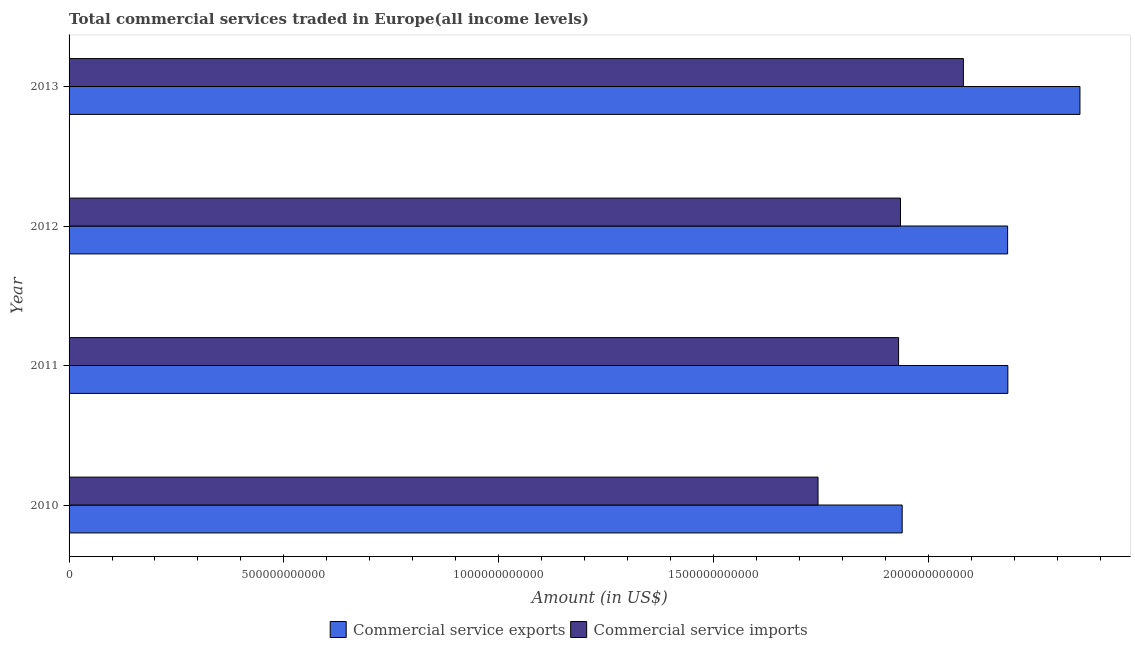Are the number of bars on each tick of the Y-axis equal?
Ensure brevity in your answer.  Yes. How many bars are there on the 2nd tick from the top?
Provide a short and direct response. 2. How many bars are there on the 1st tick from the bottom?
Keep it short and to the point. 2. What is the label of the 4th group of bars from the top?
Provide a succinct answer. 2010. In how many cases, is the number of bars for a given year not equal to the number of legend labels?
Your answer should be compact. 0. What is the amount of commercial service imports in 2013?
Your answer should be compact. 2.08e+12. Across all years, what is the maximum amount of commercial service exports?
Provide a short and direct response. 2.35e+12. Across all years, what is the minimum amount of commercial service exports?
Offer a very short reply. 1.94e+12. In which year was the amount of commercial service exports minimum?
Make the answer very short. 2010. What is the total amount of commercial service exports in the graph?
Offer a terse response. 8.66e+12. What is the difference between the amount of commercial service imports in 2011 and that in 2012?
Ensure brevity in your answer.  -4.48e+09. What is the difference between the amount of commercial service exports in 2011 and the amount of commercial service imports in 2012?
Give a very brief answer. 2.50e+11. What is the average amount of commercial service exports per year?
Your response must be concise. 2.17e+12. In the year 2011, what is the difference between the amount of commercial service exports and amount of commercial service imports?
Your answer should be compact. 2.54e+11. In how many years, is the amount of commercial service exports greater than 1100000000000 US$?
Give a very brief answer. 4. What is the ratio of the amount of commercial service imports in 2010 to that in 2011?
Your answer should be compact. 0.9. What is the difference between the highest and the second highest amount of commercial service imports?
Provide a succinct answer. 1.46e+11. What is the difference between the highest and the lowest amount of commercial service exports?
Your answer should be very brief. 4.14e+11. In how many years, is the amount of commercial service imports greater than the average amount of commercial service imports taken over all years?
Offer a very short reply. 3. Is the sum of the amount of commercial service exports in 2010 and 2012 greater than the maximum amount of commercial service imports across all years?
Your response must be concise. Yes. What does the 1st bar from the top in 2010 represents?
Your response must be concise. Commercial service imports. What does the 1st bar from the bottom in 2010 represents?
Your response must be concise. Commercial service exports. How many bars are there?
Your answer should be compact. 8. What is the difference between two consecutive major ticks on the X-axis?
Your answer should be compact. 5.00e+11. Are the values on the major ticks of X-axis written in scientific E-notation?
Offer a very short reply. No. Where does the legend appear in the graph?
Offer a terse response. Bottom center. How are the legend labels stacked?
Ensure brevity in your answer.  Horizontal. What is the title of the graph?
Give a very brief answer. Total commercial services traded in Europe(all income levels). Does "Researchers" appear as one of the legend labels in the graph?
Your response must be concise. No. What is the label or title of the Y-axis?
Offer a very short reply. Year. What is the Amount (in US$) of Commercial service exports in 2010?
Offer a very short reply. 1.94e+12. What is the Amount (in US$) of Commercial service imports in 2010?
Offer a terse response. 1.74e+12. What is the Amount (in US$) in Commercial service exports in 2011?
Your answer should be compact. 2.19e+12. What is the Amount (in US$) of Commercial service imports in 2011?
Provide a short and direct response. 1.93e+12. What is the Amount (in US$) in Commercial service exports in 2012?
Ensure brevity in your answer.  2.18e+12. What is the Amount (in US$) of Commercial service imports in 2012?
Ensure brevity in your answer.  1.94e+12. What is the Amount (in US$) in Commercial service exports in 2013?
Ensure brevity in your answer.  2.35e+12. What is the Amount (in US$) of Commercial service imports in 2013?
Provide a succinct answer. 2.08e+12. Across all years, what is the maximum Amount (in US$) of Commercial service exports?
Give a very brief answer. 2.35e+12. Across all years, what is the maximum Amount (in US$) of Commercial service imports?
Provide a short and direct response. 2.08e+12. Across all years, what is the minimum Amount (in US$) in Commercial service exports?
Your response must be concise. 1.94e+12. Across all years, what is the minimum Amount (in US$) in Commercial service imports?
Give a very brief answer. 1.74e+12. What is the total Amount (in US$) of Commercial service exports in the graph?
Offer a very short reply. 8.66e+12. What is the total Amount (in US$) in Commercial service imports in the graph?
Your answer should be very brief. 7.69e+12. What is the difference between the Amount (in US$) of Commercial service exports in 2010 and that in 2011?
Ensure brevity in your answer.  -2.46e+11. What is the difference between the Amount (in US$) in Commercial service imports in 2010 and that in 2011?
Ensure brevity in your answer.  -1.88e+11. What is the difference between the Amount (in US$) in Commercial service exports in 2010 and that in 2012?
Your response must be concise. -2.45e+11. What is the difference between the Amount (in US$) of Commercial service imports in 2010 and that in 2012?
Keep it short and to the point. -1.92e+11. What is the difference between the Amount (in US$) in Commercial service exports in 2010 and that in 2013?
Ensure brevity in your answer.  -4.14e+11. What is the difference between the Amount (in US$) of Commercial service imports in 2010 and that in 2013?
Your response must be concise. -3.38e+11. What is the difference between the Amount (in US$) of Commercial service exports in 2011 and that in 2012?
Give a very brief answer. 5.26e+08. What is the difference between the Amount (in US$) of Commercial service imports in 2011 and that in 2012?
Offer a very short reply. -4.48e+09. What is the difference between the Amount (in US$) in Commercial service exports in 2011 and that in 2013?
Keep it short and to the point. -1.68e+11. What is the difference between the Amount (in US$) of Commercial service imports in 2011 and that in 2013?
Provide a succinct answer. -1.51e+11. What is the difference between the Amount (in US$) of Commercial service exports in 2012 and that in 2013?
Your response must be concise. -1.68e+11. What is the difference between the Amount (in US$) of Commercial service imports in 2012 and that in 2013?
Give a very brief answer. -1.46e+11. What is the difference between the Amount (in US$) in Commercial service exports in 2010 and the Amount (in US$) in Commercial service imports in 2011?
Your answer should be compact. 8.33e+09. What is the difference between the Amount (in US$) in Commercial service exports in 2010 and the Amount (in US$) in Commercial service imports in 2012?
Offer a very short reply. 3.86e+09. What is the difference between the Amount (in US$) in Commercial service exports in 2010 and the Amount (in US$) in Commercial service imports in 2013?
Give a very brief answer. -1.42e+11. What is the difference between the Amount (in US$) in Commercial service exports in 2011 and the Amount (in US$) in Commercial service imports in 2012?
Offer a terse response. 2.50e+11. What is the difference between the Amount (in US$) of Commercial service exports in 2011 and the Amount (in US$) of Commercial service imports in 2013?
Provide a succinct answer. 1.04e+11. What is the difference between the Amount (in US$) in Commercial service exports in 2012 and the Amount (in US$) in Commercial service imports in 2013?
Keep it short and to the point. 1.03e+11. What is the average Amount (in US$) in Commercial service exports per year?
Make the answer very short. 2.17e+12. What is the average Amount (in US$) of Commercial service imports per year?
Your answer should be compact. 1.92e+12. In the year 2010, what is the difference between the Amount (in US$) in Commercial service exports and Amount (in US$) in Commercial service imports?
Provide a short and direct response. 1.96e+11. In the year 2011, what is the difference between the Amount (in US$) of Commercial service exports and Amount (in US$) of Commercial service imports?
Keep it short and to the point. 2.54e+11. In the year 2012, what is the difference between the Amount (in US$) of Commercial service exports and Amount (in US$) of Commercial service imports?
Your answer should be very brief. 2.49e+11. In the year 2013, what is the difference between the Amount (in US$) in Commercial service exports and Amount (in US$) in Commercial service imports?
Give a very brief answer. 2.71e+11. What is the ratio of the Amount (in US$) of Commercial service exports in 2010 to that in 2011?
Keep it short and to the point. 0.89. What is the ratio of the Amount (in US$) in Commercial service imports in 2010 to that in 2011?
Your answer should be very brief. 0.9. What is the ratio of the Amount (in US$) in Commercial service exports in 2010 to that in 2012?
Offer a very short reply. 0.89. What is the ratio of the Amount (in US$) of Commercial service imports in 2010 to that in 2012?
Offer a terse response. 0.9. What is the ratio of the Amount (in US$) of Commercial service exports in 2010 to that in 2013?
Offer a terse response. 0.82. What is the ratio of the Amount (in US$) in Commercial service imports in 2010 to that in 2013?
Keep it short and to the point. 0.84. What is the ratio of the Amount (in US$) in Commercial service exports in 2011 to that in 2013?
Your answer should be very brief. 0.93. What is the ratio of the Amount (in US$) of Commercial service imports in 2011 to that in 2013?
Keep it short and to the point. 0.93. What is the ratio of the Amount (in US$) in Commercial service exports in 2012 to that in 2013?
Your response must be concise. 0.93. What is the ratio of the Amount (in US$) of Commercial service imports in 2012 to that in 2013?
Offer a very short reply. 0.93. What is the difference between the highest and the second highest Amount (in US$) in Commercial service exports?
Give a very brief answer. 1.68e+11. What is the difference between the highest and the second highest Amount (in US$) in Commercial service imports?
Keep it short and to the point. 1.46e+11. What is the difference between the highest and the lowest Amount (in US$) of Commercial service exports?
Offer a very short reply. 4.14e+11. What is the difference between the highest and the lowest Amount (in US$) of Commercial service imports?
Your response must be concise. 3.38e+11. 